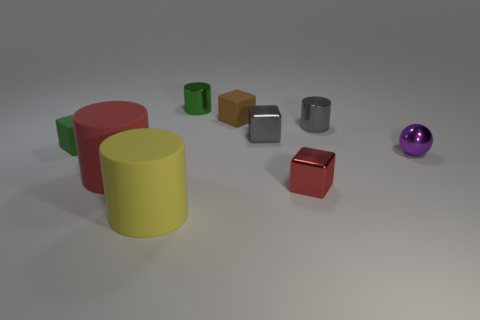What is the material of the cylinder that is right of the red block?
Keep it short and to the point. Metal. The small shiny ball has what color?
Keep it short and to the point. Purple. Is the size of the metal cube that is in front of the purple object the same as the metallic block that is behind the purple thing?
Keep it short and to the point. Yes. There is a rubber object that is both in front of the tiny gray cube and behind the red matte thing; how big is it?
Provide a succinct answer. Small. What color is the other large thing that is the same shape as the yellow matte thing?
Ensure brevity in your answer.  Red. Are there more yellow cylinders that are behind the metallic ball than tiny red objects that are left of the big red thing?
Provide a succinct answer. No. How many other objects are the same shape as the yellow thing?
Your answer should be compact. 3. There is a big thing that is behind the large yellow thing; is there a metallic sphere to the right of it?
Your response must be concise. Yes. What number of small yellow blocks are there?
Provide a short and direct response. 0. Is the color of the tiny metallic ball the same as the metallic block that is behind the big red cylinder?
Give a very brief answer. No. 